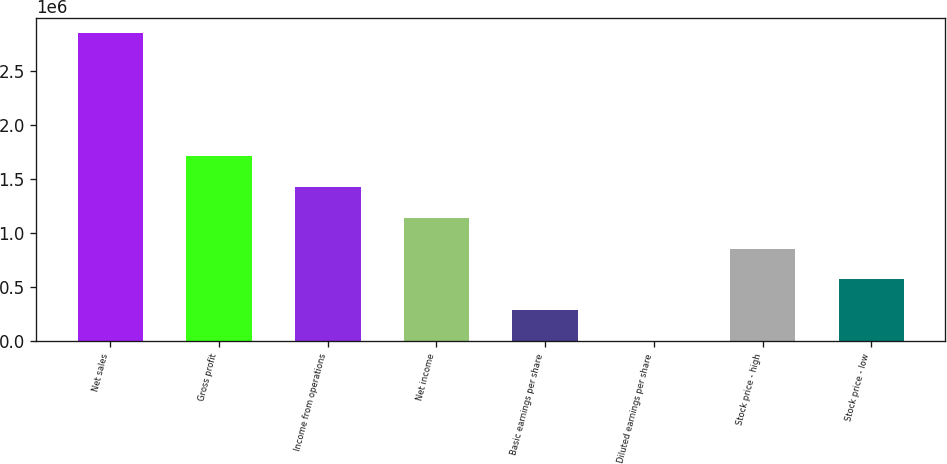Convert chart. <chart><loc_0><loc_0><loc_500><loc_500><bar_chart><fcel>Net sales<fcel>Gross profit<fcel>Income from operations<fcel>Net income<fcel>Basic earnings per share<fcel>Diluted earnings per share<fcel>Stock price - high<fcel>Stock price - low<nl><fcel>2.84388e+06<fcel>1.70633e+06<fcel>1.42194e+06<fcel>1.13755e+06<fcel>284389<fcel>1.68<fcel>853164<fcel>568777<nl></chart> 